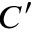Convert formula to latex. <formula><loc_0><loc_0><loc_500><loc_500>C ^ { \prime }</formula> 